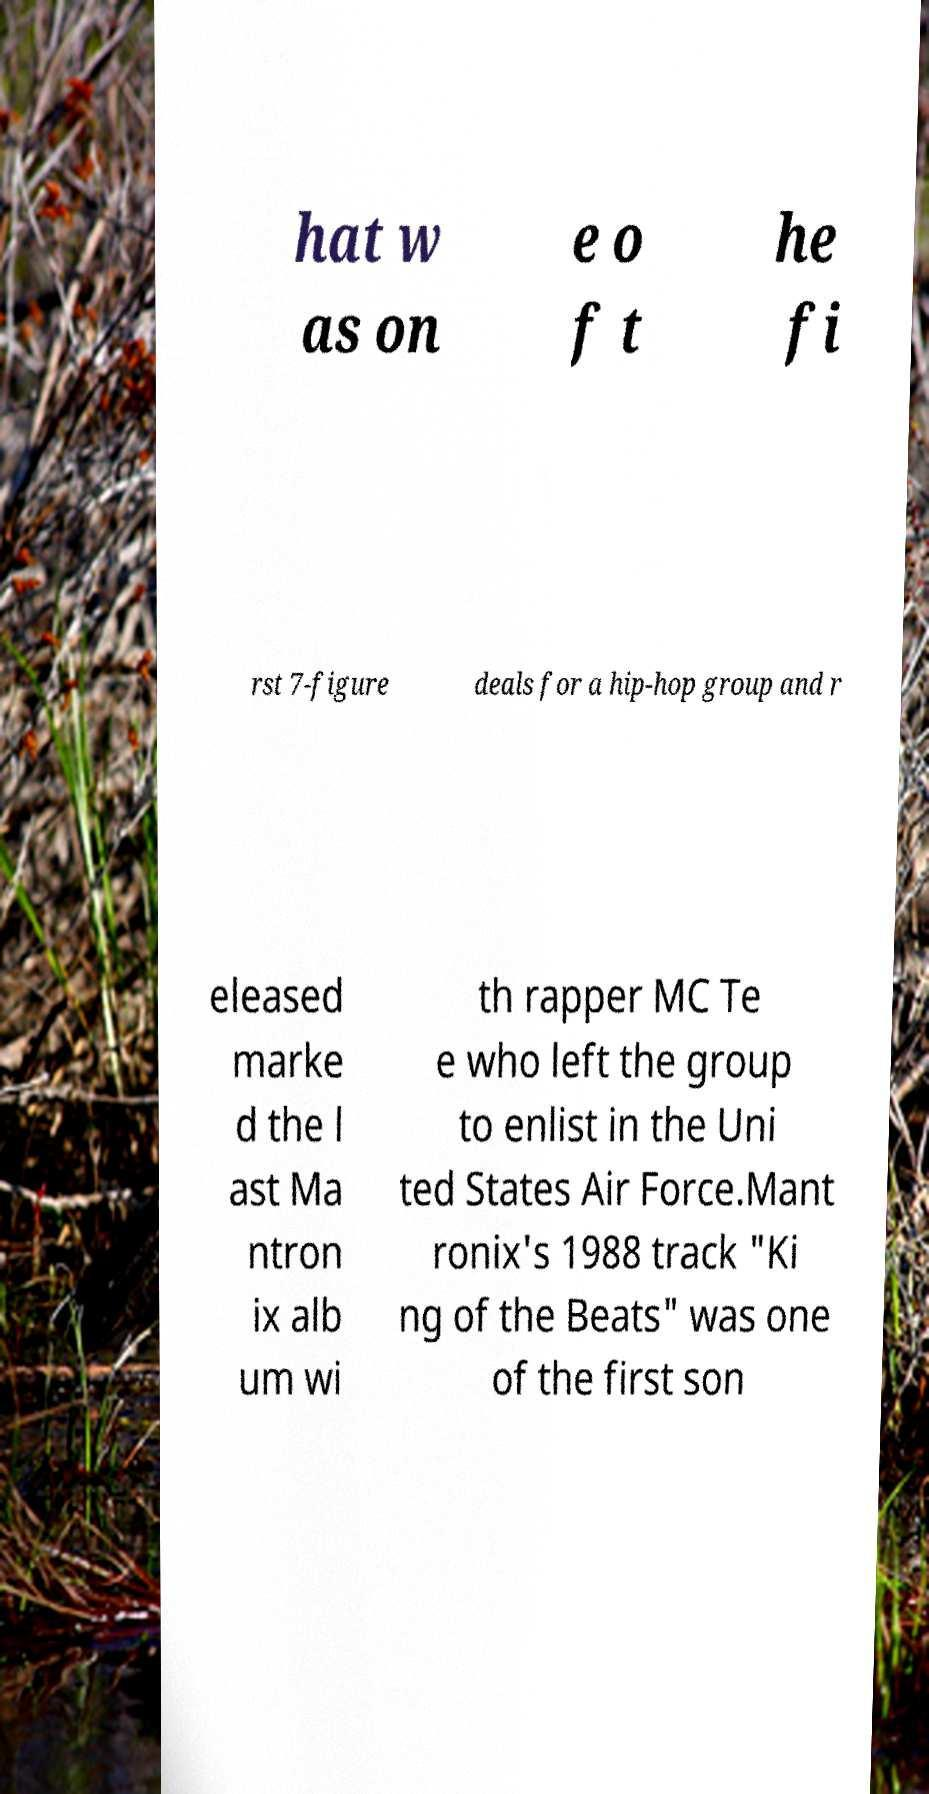Could you assist in decoding the text presented in this image and type it out clearly? hat w as on e o f t he fi rst 7-figure deals for a hip-hop group and r eleased marke d the l ast Ma ntron ix alb um wi th rapper MC Te e who left the group to enlist in the Uni ted States Air Force.Mant ronix's 1988 track "Ki ng of the Beats" was one of the first son 